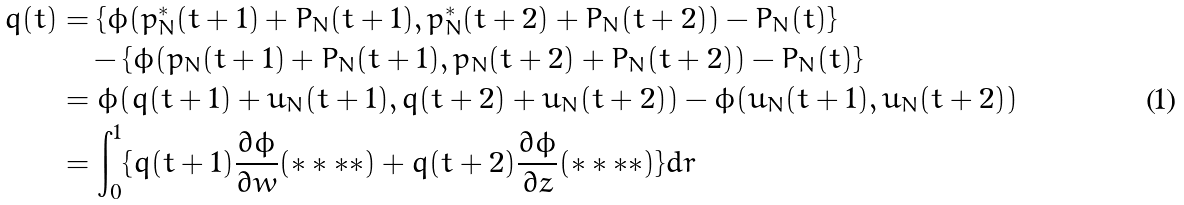Convert formula to latex. <formula><loc_0><loc_0><loc_500><loc_500>q ( t ) & = \{ \phi ( p _ { N } ^ { * } ( t + 1 ) + P _ { N } ( t + 1 ) , p _ { N } ^ { * } ( t + 2 ) + P _ { N } ( t + 2 ) ) - P _ { N } ( t ) \} \\ & \quad - \{ \phi ( p _ { N } ( t + 1 ) + P _ { N } ( t + 1 ) , p _ { N } ( t + 2 ) + P _ { N } ( t + 2 ) ) - P _ { N } ( t ) \} \\ & = \phi ( q ( t + 1 ) + u _ { N } ( t + 1 ) , q ( t + 2 ) + u _ { N } ( t + 2 ) ) - \phi ( u _ { N } ( t + 1 ) , u _ { N } ( t + 2 ) ) \\ & = \int ^ { 1 } _ { 0 } \{ q ( t + 1 ) \frac { \partial \phi } { \partial w } ( * * * * ) + q ( t + 2 ) \frac { \partial \phi } { \partial z } ( * * * * ) \} d r</formula> 